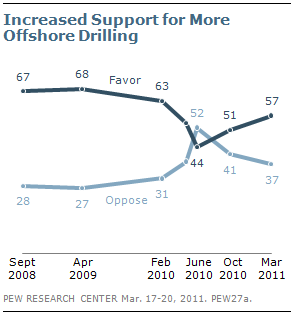Identify some key points in this picture. The peak of the gap between two lines will occur when the number is 44295. The line of favor will reach its peak at 44,295. 